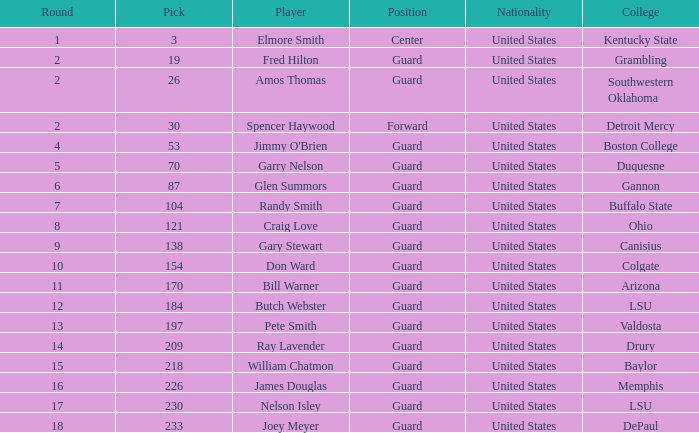WHAT COLLEGE HAS A ROUND LARGER THAN 9, WITH BUTCH WEBSTER? LSU. Would you mind parsing the complete table? {'header': ['Round', 'Pick', 'Player', 'Position', 'Nationality', 'College'], 'rows': [['1', '3', 'Elmore Smith', 'Center', 'United States', 'Kentucky State'], ['2', '19', 'Fred Hilton', 'Guard', 'United States', 'Grambling'], ['2', '26', 'Amos Thomas', 'Guard', 'United States', 'Southwestern Oklahoma'], ['2', '30', 'Spencer Haywood', 'Forward', 'United States', 'Detroit Mercy'], ['4', '53', "Jimmy O'Brien", 'Guard', 'United States', 'Boston College'], ['5', '70', 'Garry Nelson', 'Guard', 'United States', 'Duquesne'], ['6', '87', 'Glen Summors', 'Guard', 'United States', 'Gannon'], ['7', '104', 'Randy Smith', 'Guard', 'United States', 'Buffalo State'], ['8', '121', 'Craig Love', 'Guard', 'United States', 'Ohio'], ['9', '138', 'Gary Stewart', 'Guard', 'United States', 'Canisius'], ['10', '154', 'Don Ward', 'Guard', 'United States', 'Colgate'], ['11', '170', 'Bill Warner', 'Guard', 'United States', 'Arizona'], ['12', '184', 'Butch Webster', 'Guard', 'United States', 'LSU'], ['13', '197', 'Pete Smith', 'Guard', 'United States', 'Valdosta'], ['14', '209', 'Ray Lavender', 'Guard', 'United States', 'Drury'], ['15', '218', 'William Chatmon', 'Guard', 'United States', 'Baylor'], ['16', '226', 'James Douglas', 'Guard', 'United States', 'Memphis'], ['17', '230', 'Nelson Isley', 'Guard', 'United States', 'LSU'], ['18', '233', 'Joey Meyer', 'Guard', 'United States', 'DePaul']]} 